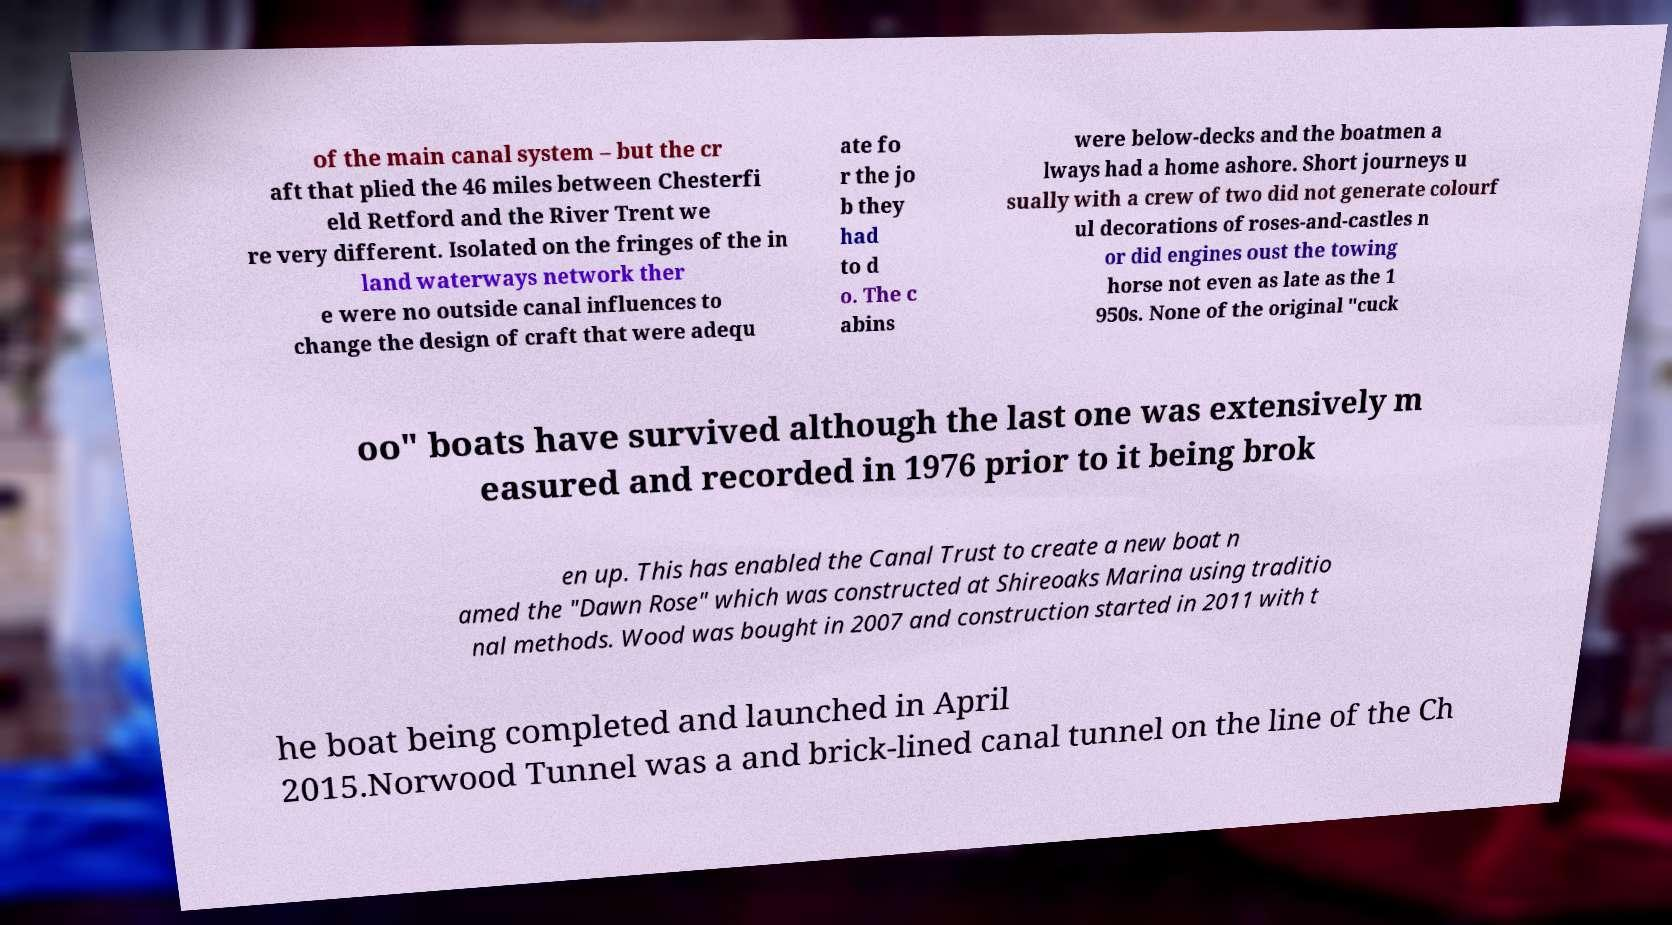Could you assist in decoding the text presented in this image and type it out clearly? of the main canal system – but the cr aft that plied the 46 miles between Chesterfi eld Retford and the River Trent we re very different. Isolated on the fringes of the in land waterways network ther e were no outside canal influences to change the design of craft that were adequ ate fo r the jo b they had to d o. The c abins were below-decks and the boatmen a lways had a home ashore. Short journeys u sually with a crew of two did not generate colourf ul decorations of roses-and-castles n or did engines oust the towing horse not even as late as the 1 950s. None of the original "cuck oo" boats have survived although the last one was extensively m easured and recorded in 1976 prior to it being brok en up. This has enabled the Canal Trust to create a new boat n amed the "Dawn Rose" which was constructed at Shireoaks Marina using traditio nal methods. Wood was bought in 2007 and construction started in 2011 with t he boat being completed and launched in April 2015.Norwood Tunnel was a and brick-lined canal tunnel on the line of the Ch 